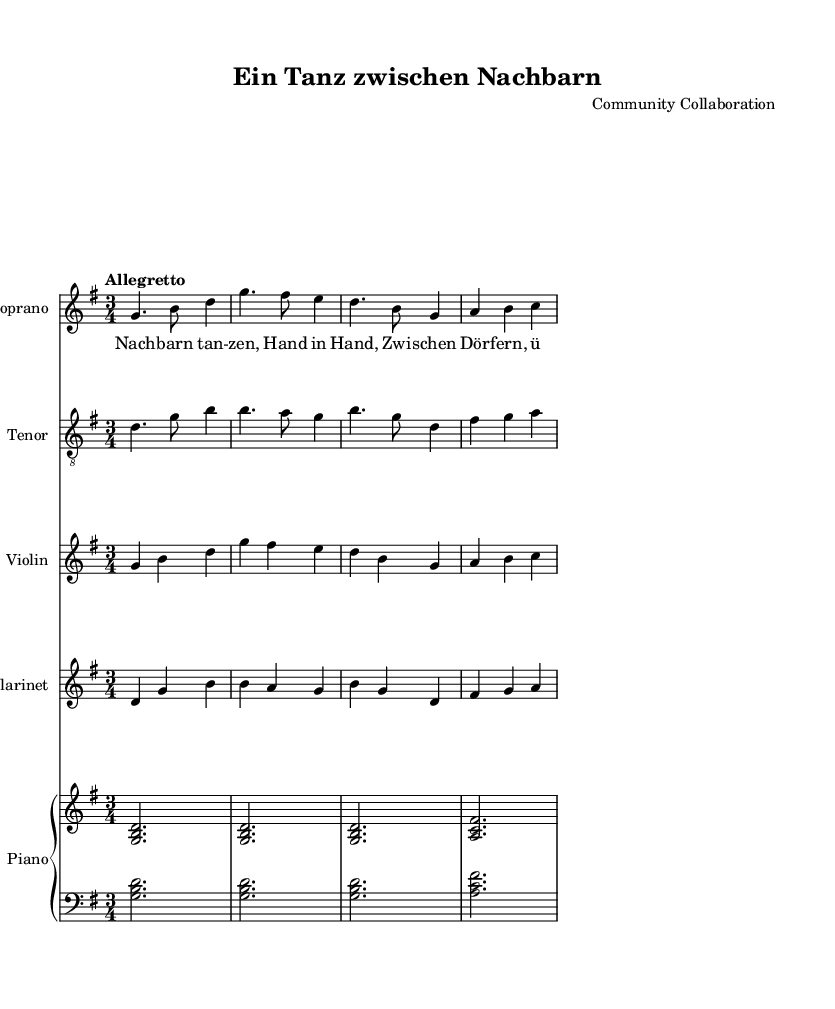What is the key signature of this music? The key signature is G major, which has one sharp (F#). You can identify it by looking at the beginning of the staff, where the sharp is indicated.
Answer: G major What is the time signature of this music? The time signature is 3/4. This can be found at the beginning of the staff, indicating that there are three beats in each measure and the quarter note gets one beat.
Answer: 3/4 What is the tempo marking for this piece? The tempo marking is "Allegretto," which is indicated at the beginning of the score. Allegretto denotes a moderately fast tempo.
Answer: Allegretto How many measures are there in the soprano part? The soprano part contains four measures, which can be counted by looking at the staff lines and identifying the groupings divided by bar lines.
Answer: 4 Which instruments are included in this score? The instruments included are soprano, tenor, violin, clarinet, and piano. You can identify them by the staff names placed at the beginning of each instrument section.
Answer: Soprano, tenor, violin, clarinet, piano What type of operatic musical format is this piece? This piece is an operetta. The combination of lighthearted comedy and charming musical numbers aligns it with the operetta genre, which is known for these characteristics.
Answer: Operetta What is the lyrical theme of the verse? The lyrical theme of the verse revolves around neighbors dancing hand in hand across different villages and lands. By reading the lyrics, you can discern the imagery of communal celebration.
Answer: Neighbors dancing 